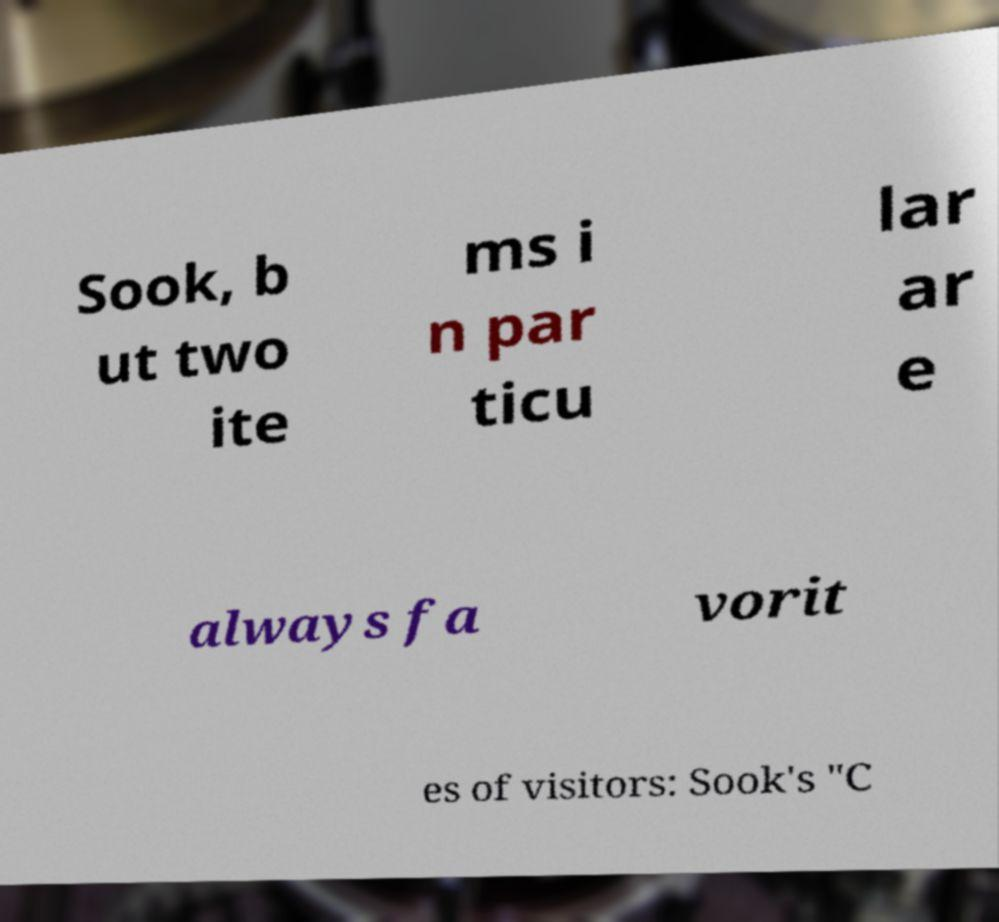What messages or text are displayed in this image? I need them in a readable, typed format. Sook, b ut two ite ms i n par ticu lar ar e always fa vorit es of visitors: Sook's "C 